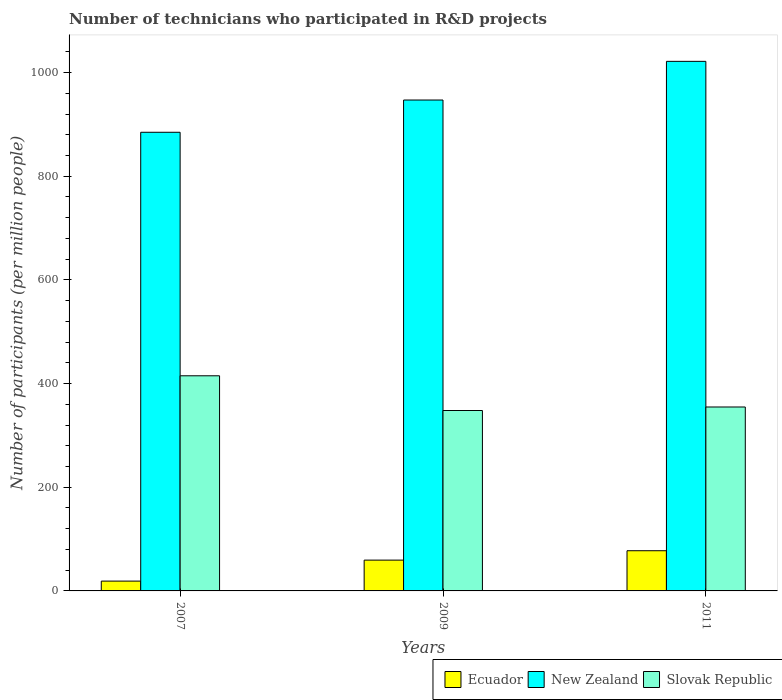How many groups of bars are there?
Keep it short and to the point. 3. Are the number of bars on each tick of the X-axis equal?
Provide a short and direct response. Yes. How many bars are there on the 2nd tick from the left?
Provide a succinct answer. 3. In how many cases, is the number of bars for a given year not equal to the number of legend labels?
Offer a very short reply. 0. What is the number of technicians who participated in R&D projects in Slovak Republic in 2007?
Offer a very short reply. 415.06. Across all years, what is the maximum number of technicians who participated in R&D projects in Slovak Republic?
Make the answer very short. 415.06. Across all years, what is the minimum number of technicians who participated in R&D projects in New Zealand?
Keep it short and to the point. 884.85. In which year was the number of technicians who participated in R&D projects in New Zealand maximum?
Keep it short and to the point. 2011. In which year was the number of technicians who participated in R&D projects in New Zealand minimum?
Provide a short and direct response. 2007. What is the total number of technicians who participated in R&D projects in New Zealand in the graph?
Make the answer very short. 2853.61. What is the difference between the number of technicians who participated in R&D projects in New Zealand in 2007 and that in 2011?
Offer a terse response. -136.84. What is the difference between the number of technicians who participated in R&D projects in Ecuador in 2007 and the number of technicians who participated in R&D projects in Slovak Republic in 2009?
Make the answer very short. -329.12. What is the average number of technicians who participated in R&D projects in Ecuador per year?
Make the answer very short. 51.97. In the year 2011, what is the difference between the number of technicians who participated in R&D projects in Ecuador and number of technicians who participated in R&D projects in Slovak Republic?
Provide a succinct answer. -277.32. What is the ratio of the number of technicians who participated in R&D projects in Slovak Republic in 2007 to that in 2009?
Your answer should be very brief. 1.19. Is the number of technicians who participated in R&D projects in New Zealand in 2007 less than that in 2011?
Your response must be concise. Yes. Is the difference between the number of technicians who participated in R&D projects in Ecuador in 2007 and 2009 greater than the difference between the number of technicians who participated in R&D projects in Slovak Republic in 2007 and 2009?
Your answer should be very brief. No. What is the difference between the highest and the second highest number of technicians who participated in R&D projects in Slovak Republic?
Offer a very short reply. 60.2. What is the difference between the highest and the lowest number of technicians who participated in R&D projects in Slovak Republic?
Your answer should be very brief. 67. In how many years, is the number of technicians who participated in R&D projects in Slovak Republic greater than the average number of technicians who participated in R&D projects in Slovak Republic taken over all years?
Offer a very short reply. 1. What does the 3rd bar from the left in 2011 represents?
Your response must be concise. Slovak Republic. What does the 2nd bar from the right in 2011 represents?
Your answer should be very brief. New Zealand. Are all the bars in the graph horizontal?
Your answer should be very brief. No. How many years are there in the graph?
Your response must be concise. 3. What is the difference between two consecutive major ticks on the Y-axis?
Offer a very short reply. 200. Does the graph contain any zero values?
Provide a short and direct response. No. How many legend labels are there?
Your answer should be very brief. 3. What is the title of the graph?
Provide a succinct answer. Number of technicians who participated in R&D projects. Does "Low & middle income" appear as one of the legend labels in the graph?
Offer a very short reply. No. What is the label or title of the X-axis?
Make the answer very short. Years. What is the label or title of the Y-axis?
Your response must be concise. Number of participants (per million people). What is the Number of participants (per million people) of Ecuador in 2007?
Your answer should be compact. 18.94. What is the Number of participants (per million people) in New Zealand in 2007?
Offer a very short reply. 884.85. What is the Number of participants (per million people) of Slovak Republic in 2007?
Provide a short and direct response. 415.06. What is the Number of participants (per million people) in Ecuador in 2009?
Keep it short and to the point. 59.44. What is the Number of participants (per million people) of New Zealand in 2009?
Your answer should be compact. 947.07. What is the Number of participants (per million people) of Slovak Republic in 2009?
Provide a short and direct response. 348.06. What is the Number of participants (per million people) in Ecuador in 2011?
Offer a very short reply. 77.54. What is the Number of participants (per million people) of New Zealand in 2011?
Provide a short and direct response. 1021.69. What is the Number of participants (per million people) of Slovak Republic in 2011?
Your answer should be compact. 354.86. Across all years, what is the maximum Number of participants (per million people) of Ecuador?
Your response must be concise. 77.54. Across all years, what is the maximum Number of participants (per million people) in New Zealand?
Your response must be concise. 1021.69. Across all years, what is the maximum Number of participants (per million people) in Slovak Republic?
Offer a terse response. 415.06. Across all years, what is the minimum Number of participants (per million people) of Ecuador?
Keep it short and to the point. 18.94. Across all years, what is the minimum Number of participants (per million people) of New Zealand?
Your response must be concise. 884.85. Across all years, what is the minimum Number of participants (per million people) in Slovak Republic?
Offer a very short reply. 348.06. What is the total Number of participants (per million people) in Ecuador in the graph?
Offer a terse response. 155.91. What is the total Number of participants (per million people) of New Zealand in the graph?
Offer a very short reply. 2853.61. What is the total Number of participants (per million people) in Slovak Republic in the graph?
Offer a terse response. 1117.98. What is the difference between the Number of participants (per million people) of Ecuador in 2007 and that in 2009?
Your answer should be very brief. -40.5. What is the difference between the Number of participants (per million people) in New Zealand in 2007 and that in 2009?
Offer a terse response. -62.23. What is the difference between the Number of participants (per million people) of Slovak Republic in 2007 and that in 2009?
Ensure brevity in your answer.  67. What is the difference between the Number of participants (per million people) in Ecuador in 2007 and that in 2011?
Your answer should be very brief. -58.6. What is the difference between the Number of participants (per million people) in New Zealand in 2007 and that in 2011?
Offer a terse response. -136.84. What is the difference between the Number of participants (per million people) of Slovak Republic in 2007 and that in 2011?
Give a very brief answer. 60.2. What is the difference between the Number of participants (per million people) in Ecuador in 2009 and that in 2011?
Keep it short and to the point. -18.1. What is the difference between the Number of participants (per million people) of New Zealand in 2009 and that in 2011?
Your answer should be very brief. -74.61. What is the difference between the Number of participants (per million people) in Slovak Republic in 2009 and that in 2011?
Your response must be concise. -6.8. What is the difference between the Number of participants (per million people) in Ecuador in 2007 and the Number of participants (per million people) in New Zealand in 2009?
Your answer should be compact. -928.14. What is the difference between the Number of participants (per million people) of Ecuador in 2007 and the Number of participants (per million people) of Slovak Republic in 2009?
Make the answer very short. -329.12. What is the difference between the Number of participants (per million people) in New Zealand in 2007 and the Number of participants (per million people) in Slovak Republic in 2009?
Offer a very short reply. 536.79. What is the difference between the Number of participants (per million people) in Ecuador in 2007 and the Number of participants (per million people) in New Zealand in 2011?
Provide a succinct answer. -1002.75. What is the difference between the Number of participants (per million people) in Ecuador in 2007 and the Number of participants (per million people) in Slovak Republic in 2011?
Ensure brevity in your answer.  -335.93. What is the difference between the Number of participants (per million people) of New Zealand in 2007 and the Number of participants (per million people) of Slovak Republic in 2011?
Give a very brief answer. 529.98. What is the difference between the Number of participants (per million people) of Ecuador in 2009 and the Number of participants (per million people) of New Zealand in 2011?
Give a very brief answer. -962.25. What is the difference between the Number of participants (per million people) of Ecuador in 2009 and the Number of participants (per million people) of Slovak Republic in 2011?
Your answer should be very brief. -295.43. What is the difference between the Number of participants (per million people) of New Zealand in 2009 and the Number of participants (per million people) of Slovak Republic in 2011?
Give a very brief answer. 592.21. What is the average Number of participants (per million people) of Ecuador per year?
Offer a very short reply. 51.97. What is the average Number of participants (per million people) of New Zealand per year?
Your answer should be very brief. 951.2. What is the average Number of participants (per million people) of Slovak Republic per year?
Your answer should be very brief. 372.66. In the year 2007, what is the difference between the Number of participants (per million people) in Ecuador and Number of participants (per million people) in New Zealand?
Provide a succinct answer. -865.91. In the year 2007, what is the difference between the Number of participants (per million people) in Ecuador and Number of participants (per million people) in Slovak Republic?
Your answer should be compact. -396.13. In the year 2007, what is the difference between the Number of participants (per million people) of New Zealand and Number of participants (per million people) of Slovak Republic?
Your answer should be very brief. 469.79. In the year 2009, what is the difference between the Number of participants (per million people) in Ecuador and Number of participants (per million people) in New Zealand?
Your response must be concise. -887.64. In the year 2009, what is the difference between the Number of participants (per million people) in Ecuador and Number of participants (per million people) in Slovak Republic?
Provide a succinct answer. -288.62. In the year 2009, what is the difference between the Number of participants (per million people) of New Zealand and Number of participants (per million people) of Slovak Republic?
Your answer should be compact. 599.01. In the year 2011, what is the difference between the Number of participants (per million people) of Ecuador and Number of participants (per million people) of New Zealand?
Keep it short and to the point. -944.15. In the year 2011, what is the difference between the Number of participants (per million people) in Ecuador and Number of participants (per million people) in Slovak Republic?
Offer a very short reply. -277.32. In the year 2011, what is the difference between the Number of participants (per million people) of New Zealand and Number of participants (per million people) of Slovak Republic?
Keep it short and to the point. 666.82. What is the ratio of the Number of participants (per million people) in Ecuador in 2007 to that in 2009?
Ensure brevity in your answer.  0.32. What is the ratio of the Number of participants (per million people) of New Zealand in 2007 to that in 2009?
Provide a succinct answer. 0.93. What is the ratio of the Number of participants (per million people) in Slovak Republic in 2007 to that in 2009?
Your answer should be compact. 1.19. What is the ratio of the Number of participants (per million people) in Ecuador in 2007 to that in 2011?
Your response must be concise. 0.24. What is the ratio of the Number of participants (per million people) in New Zealand in 2007 to that in 2011?
Provide a short and direct response. 0.87. What is the ratio of the Number of participants (per million people) in Slovak Republic in 2007 to that in 2011?
Offer a very short reply. 1.17. What is the ratio of the Number of participants (per million people) of Ecuador in 2009 to that in 2011?
Make the answer very short. 0.77. What is the ratio of the Number of participants (per million people) of New Zealand in 2009 to that in 2011?
Your answer should be very brief. 0.93. What is the ratio of the Number of participants (per million people) of Slovak Republic in 2009 to that in 2011?
Give a very brief answer. 0.98. What is the difference between the highest and the second highest Number of participants (per million people) in Ecuador?
Ensure brevity in your answer.  18.1. What is the difference between the highest and the second highest Number of participants (per million people) in New Zealand?
Offer a very short reply. 74.61. What is the difference between the highest and the second highest Number of participants (per million people) in Slovak Republic?
Your answer should be compact. 60.2. What is the difference between the highest and the lowest Number of participants (per million people) in Ecuador?
Your answer should be compact. 58.6. What is the difference between the highest and the lowest Number of participants (per million people) of New Zealand?
Ensure brevity in your answer.  136.84. What is the difference between the highest and the lowest Number of participants (per million people) of Slovak Republic?
Provide a short and direct response. 67. 